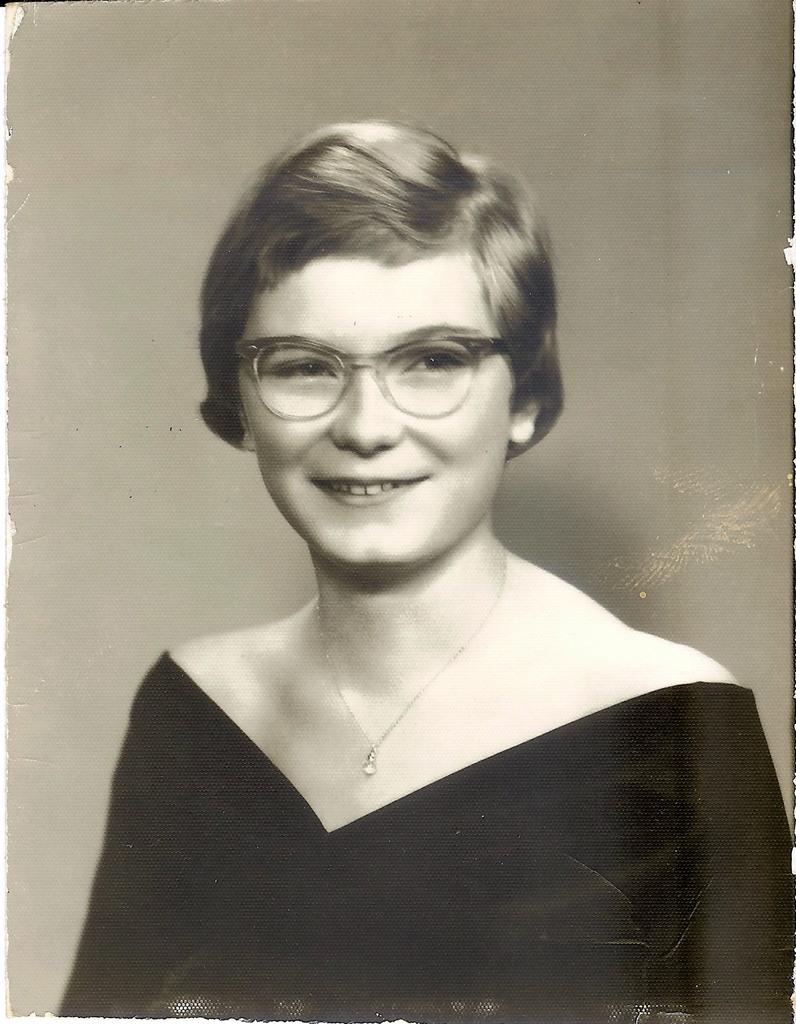What is the color scheme of the image? The image is black and white. Who is present in the image? There is a woman in the image. What is the woman doing in the image? The woman is smiling. What accessory is the woman wearing in the image? The woman is wearing spectacles. What type of glue is being used to fix the waste in the image? There is no glue or waste present in the image; it features a woman who is smiling and wearing spectacles. 